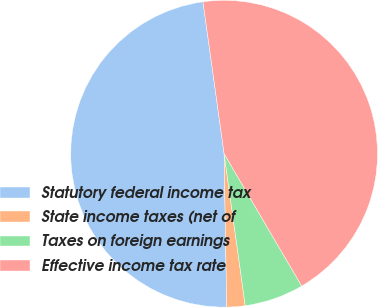Convert chart to OTSL. <chart><loc_0><loc_0><loc_500><loc_500><pie_chart><fcel>Statutory federal income tax<fcel>State income taxes (net of<fcel>Taxes on foreign earnings<fcel>Effective income tax rate<nl><fcel>48.07%<fcel>1.93%<fcel>6.24%<fcel>43.76%<nl></chart> 